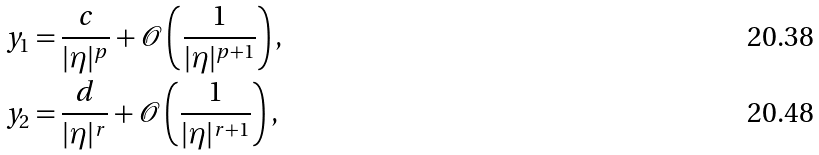<formula> <loc_0><loc_0><loc_500><loc_500>y _ { 1 } & = \frac { c } { | \eta | ^ { p } } + { \mathcal { O } } \left ( \frac { 1 } { | \eta | ^ { p + 1 } } \right ) , \\ y _ { 2 } & = \frac { d } { | \eta | ^ { r } } + { \mathcal { O } } \left ( \frac { 1 } { | \eta | ^ { r + 1 } } \right ) ,</formula> 